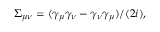Convert formula to latex. <formula><loc_0><loc_0><loc_500><loc_500>\Sigma _ { \mu \nu } = ( \gamma _ { \mu } \gamma _ { \nu } - \gamma _ { \nu } \gamma _ { \mu } ) / ( 2 i ) ,</formula> 